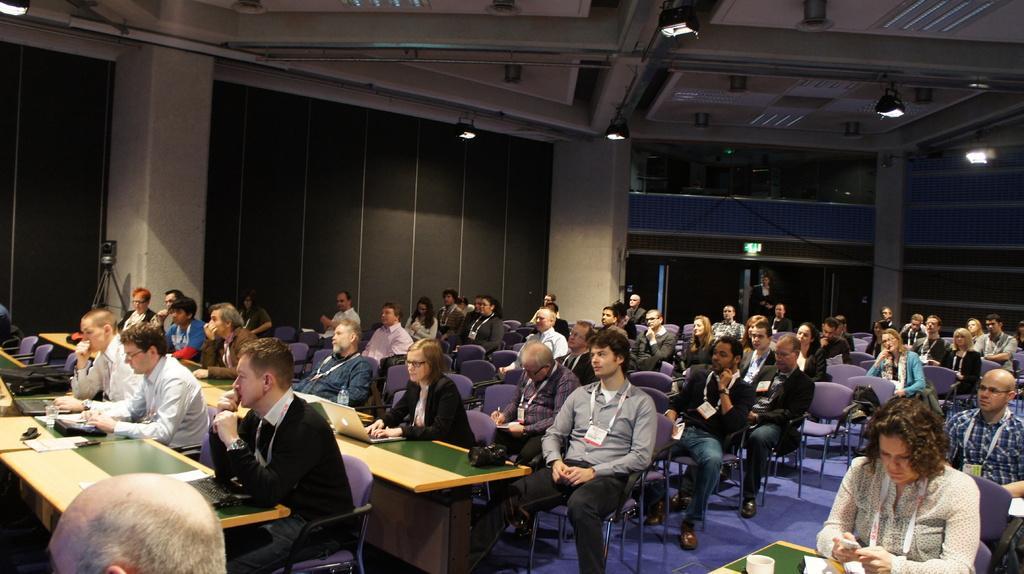How would you summarize this image in a sentence or two? In this image there are group of people sitting on the chairs , and on the tables there are laptops, papers, cup, tissues and some objects, lights. 